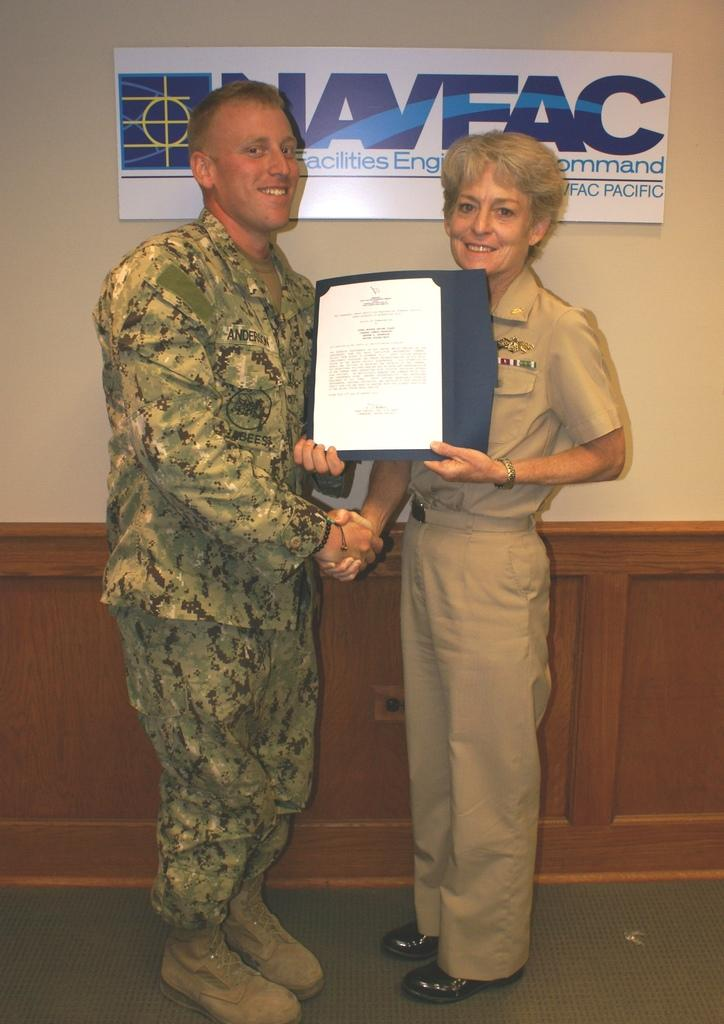<image>
Provide a brief description of the given image. a man getting a award with the word Naveac behind him 